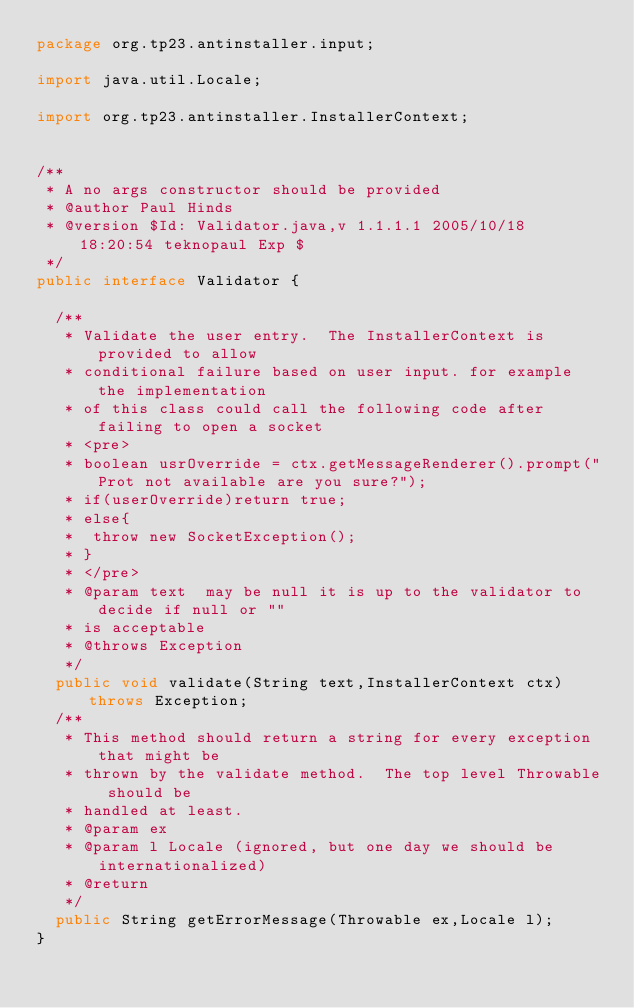<code> <loc_0><loc_0><loc_500><loc_500><_Java_>package org.tp23.antinstaller.input;

import java.util.Locale;

import org.tp23.antinstaller.InstallerContext;


/**
 * A no args constructor should be provided
 * @author Paul Hinds
 * @version $Id: Validator.java,v 1.1.1.1 2005/10/18 18:20:54 teknopaul Exp $
 */
public interface Validator {

	/**
	 * Validate the user entry.  The InstallerContext is provided to allow
	 * conditional failure based on user input. for example the implementation
	 * of this class could call the following code after failing to open a socket
	 * <pre>
	 * boolean usrOverride = ctx.getMessageRenderer().prompt("Prot not available are you sure?");
	 * if(userOverride)return true;
	 * else{
	 * 	throw new SocketException();
	 * }
	 * </pre>
	 * @param text  may be null it is up to the validator to decide if null or ""
	 * is acceptable
	 * @throws Exception
	 */
	public void validate(String text,InstallerContext ctx)throws Exception;
	/**
	 * This method should return a string for every exception that might be 
	 * thrown by the validate method.  The top level Throwable should be 
	 * handled at least.  
	 * @param ex
	 * @param l Locale (ignored, but one day we should be internationalized)
	 * @return
	 */
	public String getErrorMessage(Throwable ex,Locale l);
}
</code> 